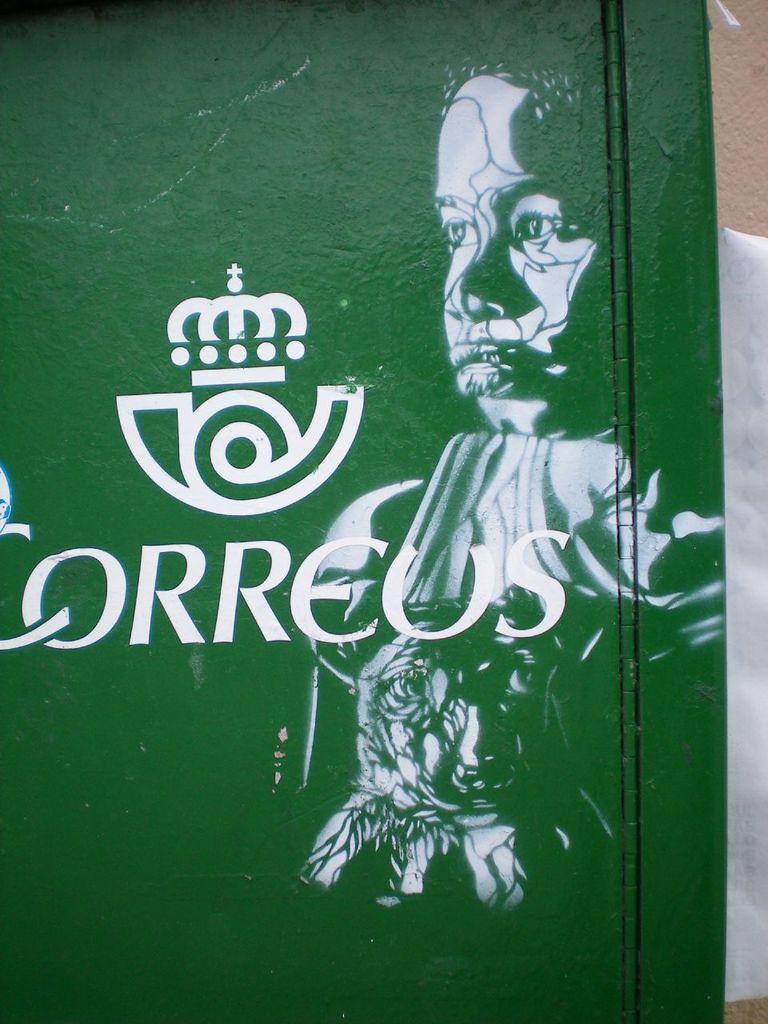Please provide a concise description of this image. In the picture I can see a painting of a person and some other thing. I can also see something written on a green color wall. 